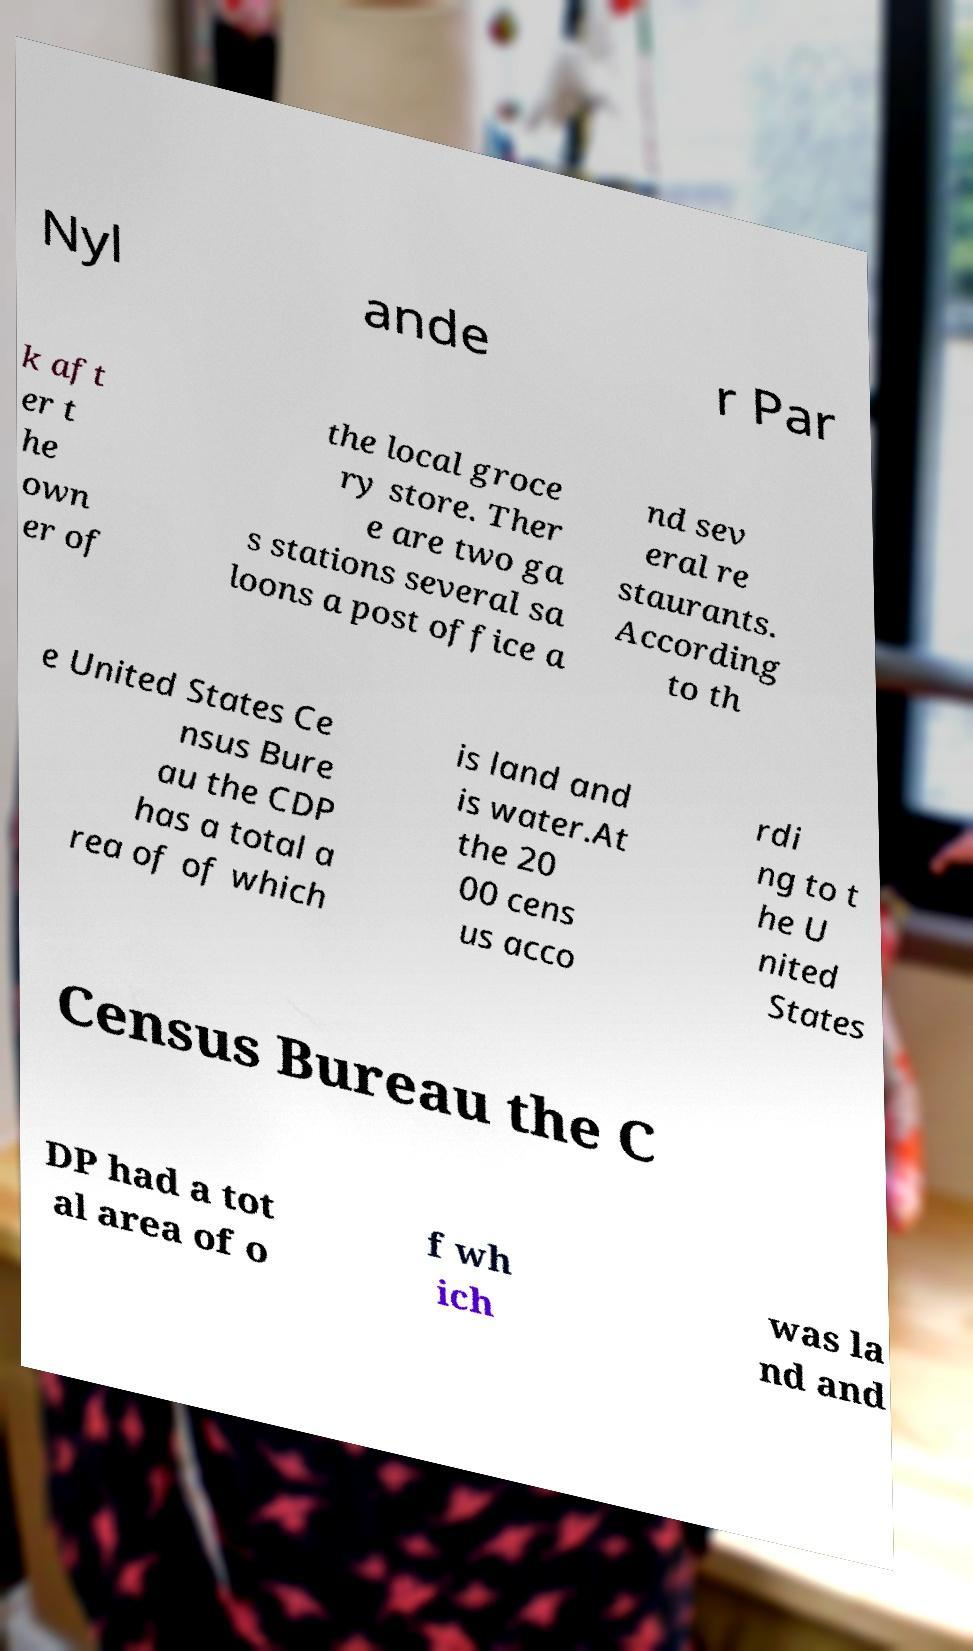There's text embedded in this image that I need extracted. Can you transcribe it verbatim? Nyl ande r Par k aft er t he own er of the local groce ry store. Ther e are two ga s stations several sa loons a post office a nd sev eral re staurants. According to th e United States Ce nsus Bure au the CDP has a total a rea of of which is land and is water.At the 20 00 cens us acco rdi ng to t he U nited States Census Bureau the C DP had a tot al area of o f wh ich was la nd and 